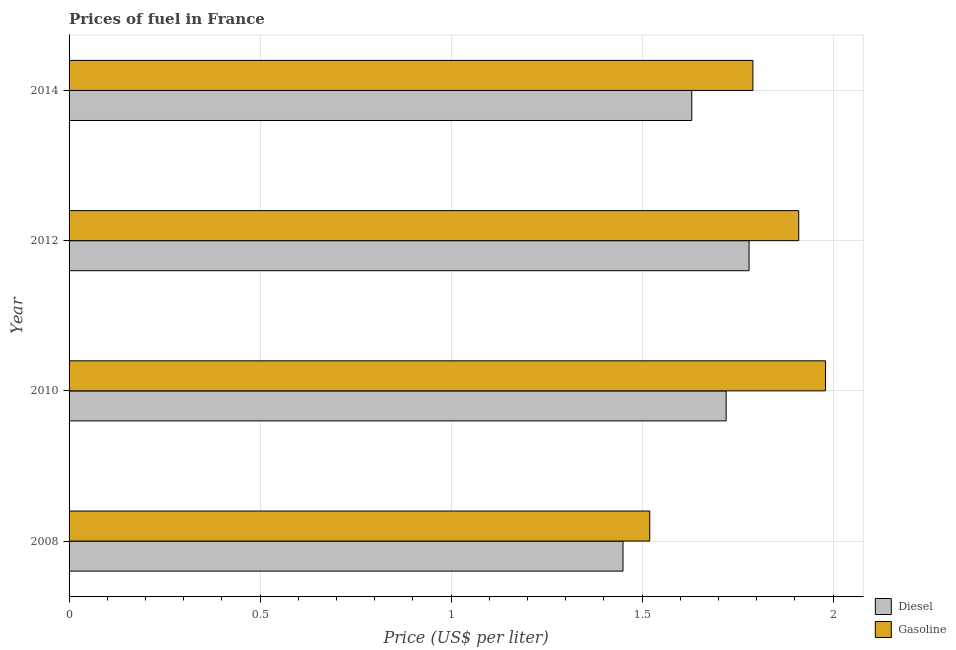How many different coloured bars are there?
Provide a succinct answer. 2. How many bars are there on the 3rd tick from the top?
Your answer should be compact. 2. What is the label of the 1st group of bars from the top?
Your response must be concise. 2014. What is the diesel price in 2012?
Keep it short and to the point. 1.78. Across all years, what is the maximum diesel price?
Your response must be concise. 1.78. Across all years, what is the minimum gasoline price?
Provide a succinct answer. 1.52. In which year was the gasoline price maximum?
Your answer should be very brief. 2010. What is the total diesel price in the graph?
Offer a very short reply. 6.58. What is the difference between the gasoline price in 2010 and that in 2014?
Your response must be concise. 0.19. What is the difference between the diesel price in 2014 and the gasoline price in 2012?
Make the answer very short. -0.28. What is the average gasoline price per year?
Give a very brief answer. 1.8. In the year 2008, what is the difference between the diesel price and gasoline price?
Your answer should be compact. -0.07. What is the ratio of the diesel price in 2008 to that in 2012?
Keep it short and to the point. 0.81. Is the difference between the diesel price in 2008 and 2012 greater than the difference between the gasoline price in 2008 and 2012?
Offer a terse response. Yes. What is the difference between the highest and the second highest gasoline price?
Keep it short and to the point. 0.07. What is the difference between the highest and the lowest gasoline price?
Keep it short and to the point. 0.46. In how many years, is the gasoline price greater than the average gasoline price taken over all years?
Ensure brevity in your answer.  2. What does the 2nd bar from the top in 2014 represents?
Your response must be concise. Diesel. What does the 2nd bar from the bottom in 2010 represents?
Ensure brevity in your answer.  Gasoline. How many bars are there?
Offer a very short reply. 8. Are the values on the major ticks of X-axis written in scientific E-notation?
Keep it short and to the point. No. Where does the legend appear in the graph?
Provide a short and direct response. Bottom right. How many legend labels are there?
Your answer should be compact. 2. How are the legend labels stacked?
Ensure brevity in your answer.  Vertical. What is the title of the graph?
Keep it short and to the point. Prices of fuel in France. Does "Private funds" appear as one of the legend labels in the graph?
Keep it short and to the point. No. What is the label or title of the X-axis?
Give a very brief answer. Price (US$ per liter). What is the Price (US$ per liter) in Diesel in 2008?
Offer a terse response. 1.45. What is the Price (US$ per liter) in Gasoline in 2008?
Give a very brief answer. 1.52. What is the Price (US$ per liter) of Diesel in 2010?
Offer a very short reply. 1.72. What is the Price (US$ per liter) of Gasoline in 2010?
Offer a terse response. 1.98. What is the Price (US$ per liter) of Diesel in 2012?
Make the answer very short. 1.78. What is the Price (US$ per liter) in Gasoline in 2012?
Give a very brief answer. 1.91. What is the Price (US$ per liter) in Diesel in 2014?
Provide a succinct answer. 1.63. What is the Price (US$ per liter) of Gasoline in 2014?
Offer a very short reply. 1.79. Across all years, what is the maximum Price (US$ per liter) of Diesel?
Your answer should be compact. 1.78. Across all years, what is the maximum Price (US$ per liter) in Gasoline?
Your answer should be compact. 1.98. Across all years, what is the minimum Price (US$ per liter) of Diesel?
Provide a short and direct response. 1.45. Across all years, what is the minimum Price (US$ per liter) in Gasoline?
Provide a short and direct response. 1.52. What is the total Price (US$ per liter) of Diesel in the graph?
Your answer should be very brief. 6.58. What is the difference between the Price (US$ per liter) in Diesel in 2008 and that in 2010?
Provide a succinct answer. -0.27. What is the difference between the Price (US$ per liter) in Gasoline in 2008 and that in 2010?
Provide a succinct answer. -0.46. What is the difference between the Price (US$ per liter) in Diesel in 2008 and that in 2012?
Keep it short and to the point. -0.33. What is the difference between the Price (US$ per liter) of Gasoline in 2008 and that in 2012?
Keep it short and to the point. -0.39. What is the difference between the Price (US$ per liter) of Diesel in 2008 and that in 2014?
Give a very brief answer. -0.18. What is the difference between the Price (US$ per liter) in Gasoline in 2008 and that in 2014?
Provide a short and direct response. -0.27. What is the difference between the Price (US$ per liter) of Diesel in 2010 and that in 2012?
Provide a short and direct response. -0.06. What is the difference between the Price (US$ per liter) in Gasoline in 2010 and that in 2012?
Your answer should be compact. 0.07. What is the difference between the Price (US$ per liter) of Diesel in 2010 and that in 2014?
Keep it short and to the point. 0.09. What is the difference between the Price (US$ per liter) in Gasoline in 2010 and that in 2014?
Your response must be concise. 0.19. What is the difference between the Price (US$ per liter) in Diesel in 2012 and that in 2014?
Make the answer very short. 0.15. What is the difference between the Price (US$ per liter) of Gasoline in 2012 and that in 2014?
Make the answer very short. 0.12. What is the difference between the Price (US$ per liter) of Diesel in 2008 and the Price (US$ per liter) of Gasoline in 2010?
Give a very brief answer. -0.53. What is the difference between the Price (US$ per liter) in Diesel in 2008 and the Price (US$ per liter) in Gasoline in 2012?
Your answer should be very brief. -0.46. What is the difference between the Price (US$ per liter) in Diesel in 2008 and the Price (US$ per liter) in Gasoline in 2014?
Provide a succinct answer. -0.34. What is the difference between the Price (US$ per liter) of Diesel in 2010 and the Price (US$ per liter) of Gasoline in 2012?
Provide a succinct answer. -0.19. What is the difference between the Price (US$ per liter) in Diesel in 2010 and the Price (US$ per liter) in Gasoline in 2014?
Keep it short and to the point. -0.07. What is the difference between the Price (US$ per liter) in Diesel in 2012 and the Price (US$ per liter) in Gasoline in 2014?
Give a very brief answer. -0.01. What is the average Price (US$ per liter) in Diesel per year?
Your response must be concise. 1.65. In the year 2008, what is the difference between the Price (US$ per liter) in Diesel and Price (US$ per liter) in Gasoline?
Your answer should be very brief. -0.07. In the year 2010, what is the difference between the Price (US$ per liter) of Diesel and Price (US$ per liter) of Gasoline?
Provide a succinct answer. -0.26. In the year 2012, what is the difference between the Price (US$ per liter) of Diesel and Price (US$ per liter) of Gasoline?
Keep it short and to the point. -0.13. In the year 2014, what is the difference between the Price (US$ per liter) in Diesel and Price (US$ per liter) in Gasoline?
Your answer should be very brief. -0.16. What is the ratio of the Price (US$ per liter) of Diesel in 2008 to that in 2010?
Make the answer very short. 0.84. What is the ratio of the Price (US$ per liter) of Gasoline in 2008 to that in 2010?
Give a very brief answer. 0.77. What is the ratio of the Price (US$ per liter) in Diesel in 2008 to that in 2012?
Your answer should be very brief. 0.81. What is the ratio of the Price (US$ per liter) of Gasoline in 2008 to that in 2012?
Offer a very short reply. 0.8. What is the ratio of the Price (US$ per liter) in Diesel in 2008 to that in 2014?
Make the answer very short. 0.89. What is the ratio of the Price (US$ per liter) in Gasoline in 2008 to that in 2014?
Give a very brief answer. 0.85. What is the ratio of the Price (US$ per liter) in Diesel in 2010 to that in 2012?
Provide a succinct answer. 0.97. What is the ratio of the Price (US$ per liter) in Gasoline in 2010 to that in 2012?
Ensure brevity in your answer.  1.04. What is the ratio of the Price (US$ per liter) of Diesel in 2010 to that in 2014?
Keep it short and to the point. 1.06. What is the ratio of the Price (US$ per liter) in Gasoline in 2010 to that in 2014?
Offer a terse response. 1.11. What is the ratio of the Price (US$ per liter) of Diesel in 2012 to that in 2014?
Your answer should be very brief. 1.09. What is the ratio of the Price (US$ per liter) of Gasoline in 2012 to that in 2014?
Offer a terse response. 1.07. What is the difference between the highest and the second highest Price (US$ per liter) of Gasoline?
Ensure brevity in your answer.  0.07. What is the difference between the highest and the lowest Price (US$ per liter) in Diesel?
Your answer should be very brief. 0.33. What is the difference between the highest and the lowest Price (US$ per liter) of Gasoline?
Provide a succinct answer. 0.46. 